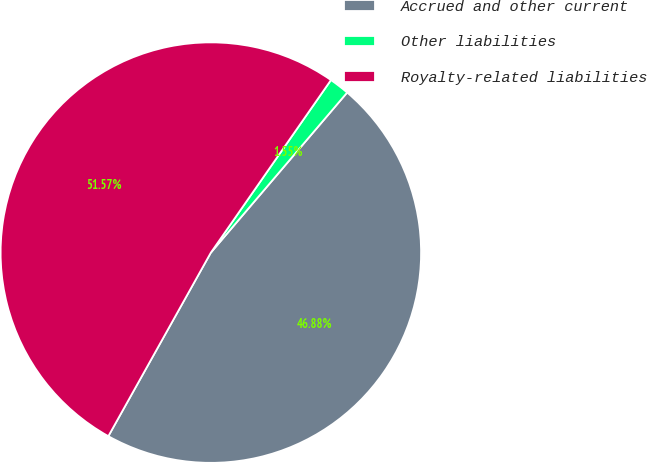Convert chart. <chart><loc_0><loc_0><loc_500><loc_500><pie_chart><fcel>Accrued and other current<fcel>Other liabilities<fcel>Royalty-related liabilities<nl><fcel>46.88%<fcel>1.55%<fcel>51.57%<nl></chart> 